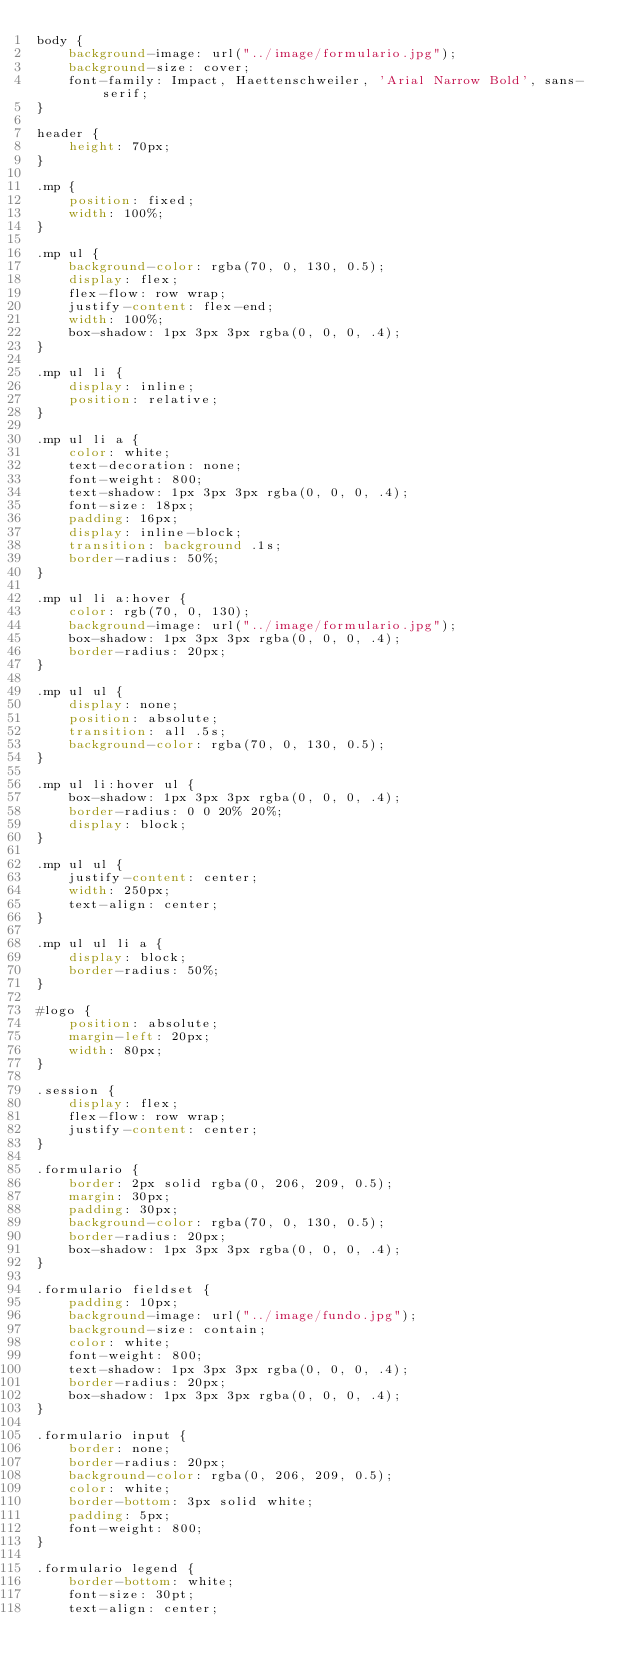<code> <loc_0><loc_0><loc_500><loc_500><_CSS_>body {
    background-image: url("../image/formulario.jpg");
    background-size: cover;
    font-family: Impact, Haettenschweiler, 'Arial Narrow Bold', sans-serif;
}

header {
    height: 70px;
}

.mp {
    position: fixed;
    width: 100%;
}

.mp ul {
    background-color: rgba(70, 0, 130, 0.5);
    display: flex;
    flex-flow: row wrap;
    justify-content: flex-end;
    width: 100%;
    box-shadow: 1px 3px 3px rgba(0, 0, 0, .4);
}

.mp ul li {
    display: inline;
    position: relative;
}

.mp ul li a {
    color: white;
    text-decoration: none;
    font-weight: 800;
    text-shadow: 1px 3px 3px rgba(0, 0, 0, .4);
    font-size: 18px;
    padding: 16px;
    display: inline-block;
    transition: background .1s;
    border-radius: 50%;
}

.mp ul li a:hover {
    color: rgb(70, 0, 130);
    background-image: url("../image/formulario.jpg");
    box-shadow: 1px 3px 3px rgba(0, 0, 0, .4);
    border-radius: 20px;
}

.mp ul ul {
    display: none;
    position: absolute;
    transition: all .5s;
    background-color: rgba(70, 0, 130, 0.5);
}

.mp ul li:hover ul {
    box-shadow: 1px 3px 3px rgba(0, 0, 0, .4);
    border-radius: 0 0 20% 20%;
    display: block;
}

.mp ul ul {
    justify-content: center;
    width: 250px;
    text-align: center;
}

.mp ul ul li a {
    display: block;
    border-radius: 50%;
}

#logo {
    position: absolute;
    margin-left: 20px;
    width: 80px;
}

.session {
    display: flex;
    flex-flow: row wrap;
    justify-content: center;
}

.formulario {
    border: 2px solid rgba(0, 206, 209, 0.5);
    margin: 30px;
    padding: 30px;
    background-color: rgba(70, 0, 130, 0.5);
    border-radius: 20px;
    box-shadow: 1px 3px 3px rgba(0, 0, 0, .4);
}

.formulario fieldset {
    padding: 10px;
    background-image: url("../image/fundo.jpg");
    background-size: contain;
    color: white;
    font-weight: 800;
    text-shadow: 1px 3px 3px rgba(0, 0, 0, .4);
    border-radius: 20px;
    box-shadow: 1px 3px 3px rgba(0, 0, 0, .4);
}

.formulario input {
    border: none;
    border-radius: 20px;
    background-color: rgba(0, 206, 209, 0.5);
    color: white;
    border-bottom: 3px solid white;
    padding: 5px;
    font-weight: 800;
}

.formulario legend {
    border-bottom: white;
    font-size: 30pt;
    text-align: center;</code> 